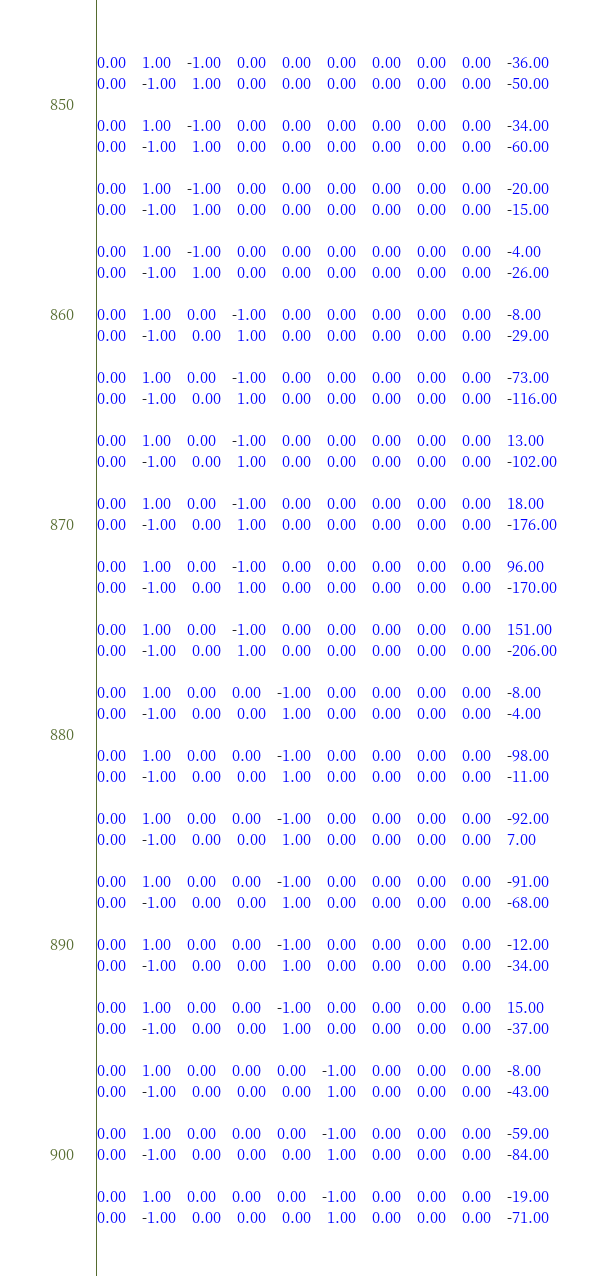Convert code to text. <code><loc_0><loc_0><loc_500><loc_500><_Matlab_>
0.00	1.00	-1.00	0.00	0.00	0.00	0.00	0.00	0.00	-36.00
0.00	-1.00	1.00	0.00	0.00	0.00	0.00	0.00	0.00	-50.00

0.00	1.00	-1.00	0.00	0.00	0.00	0.00	0.00	0.00	-34.00
0.00	-1.00	1.00	0.00	0.00	0.00	0.00	0.00	0.00	-60.00

0.00	1.00	-1.00	0.00	0.00	0.00	0.00	0.00	0.00	-20.00
0.00	-1.00	1.00	0.00	0.00	0.00	0.00	0.00	0.00	-15.00

0.00	1.00	-1.00	0.00	0.00	0.00	0.00	0.00	0.00	-4.00
0.00	-1.00	1.00	0.00	0.00	0.00	0.00	0.00	0.00	-26.00

0.00	1.00	0.00	-1.00	0.00	0.00	0.00	0.00	0.00	-8.00
0.00	-1.00	0.00	1.00	0.00	0.00	0.00	0.00	0.00	-29.00

0.00	1.00	0.00	-1.00	0.00	0.00	0.00	0.00	0.00	-73.00
0.00	-1.00	0.00	1.00	0.00	0.00	0.00	0.00	0.00	-116.00

0.00	1.00	0.00	-1.00	0.00	0.00	0.00	0.00	0.00	13.00
0.00	-1.00	0.00	1.00	0.00	0.00	0.00	0.00	0.00	-102.00

0.00	1.00	0.00	-1.00	0.00	0.00	0.00	0.00	0.00	18.00
0.00	-1.00	0.00	1.00	0.00	0.00	0.00	0.00	0.00	-176.00

0.00	1.00	0.00	-1.00	0.00	0.00	0.00	0.00	0.00	96.00
0.00	-1.00	0.00	1.00	0.00	0.00	0.00	0.00	0.00	-170.00

0.00	1.00	0.00	-1.00	0.00	0.00	0.00	0.00	0.00	151.00
0.00	-1.00	0.00	1.00	0.00	0.00	0.00	0.00	0.00	-206.00

0.00	1.00	0.00	0.00	-1.00	0.00	0.00	0.00	0.00	-8.00
0.00	-1.00	0.00	0.00	1.00	0.00	0.00	0.00	0.00	-4.00

0.00	1.00	0.00	0.00	-1.00	0.00	0.00	0.00	0.00	-98.00
0.00	-1.00	0.00	0.00	1.00	0.00	0.00	0.00	0.00	-11.00

0.00	1.00	0.00	0.00	-1.00	0.00	0.00	0.00	0.00	-92.00
0.00	-1.00	0.00	0.00	1.00	0.00	0.00	0.00	0.00	7.00

0.00	1.00	0.00	0.00	-1.00	0.00	0.00	0.00	0.00	-91.00
0.00	-1.00	0.00	0.00	1.00	0.00	0.00	0.00	0.00	-68.00

0.00	1.00	0.00	0.00	-1.00	0.00	0.00	0.00	0.00	-12.00
0.00	-1.00	0.00	0.00	1.00	0.00	0.00	0.00	0.00	-34.00

0.00	1.00	0.00	0.00	-1.00	0.00	0.00	0.00	0.00	15.00
0.00	-1.00	0.00	0.00	1.00	0.00	0.00	0.00	0.00	-37.00

0.00	1.00	0.00	0.00	0.00	-1.00	0.00	0.00	0.00	-8.00
0.00	-1.00	0.00	0.00	0.00	1.00	0.00	0.00	0.00	-43.00

0.00	1.00	0.00	0.00	0.00	-1.00	0.00	0.00	0.00	-59.00
0.00	-1.00	0.00	0.00	0.00	1.00	0.00	0.00	0.00	-84.00

0.00	1.00	0.00	0.00	0.00	-1.00	0.00	0.00	0.00	-19.00
0.00	-1.00	0.00	0.00	0.00	1.00	0.00	0.00	0.00	-71.00
</code> 